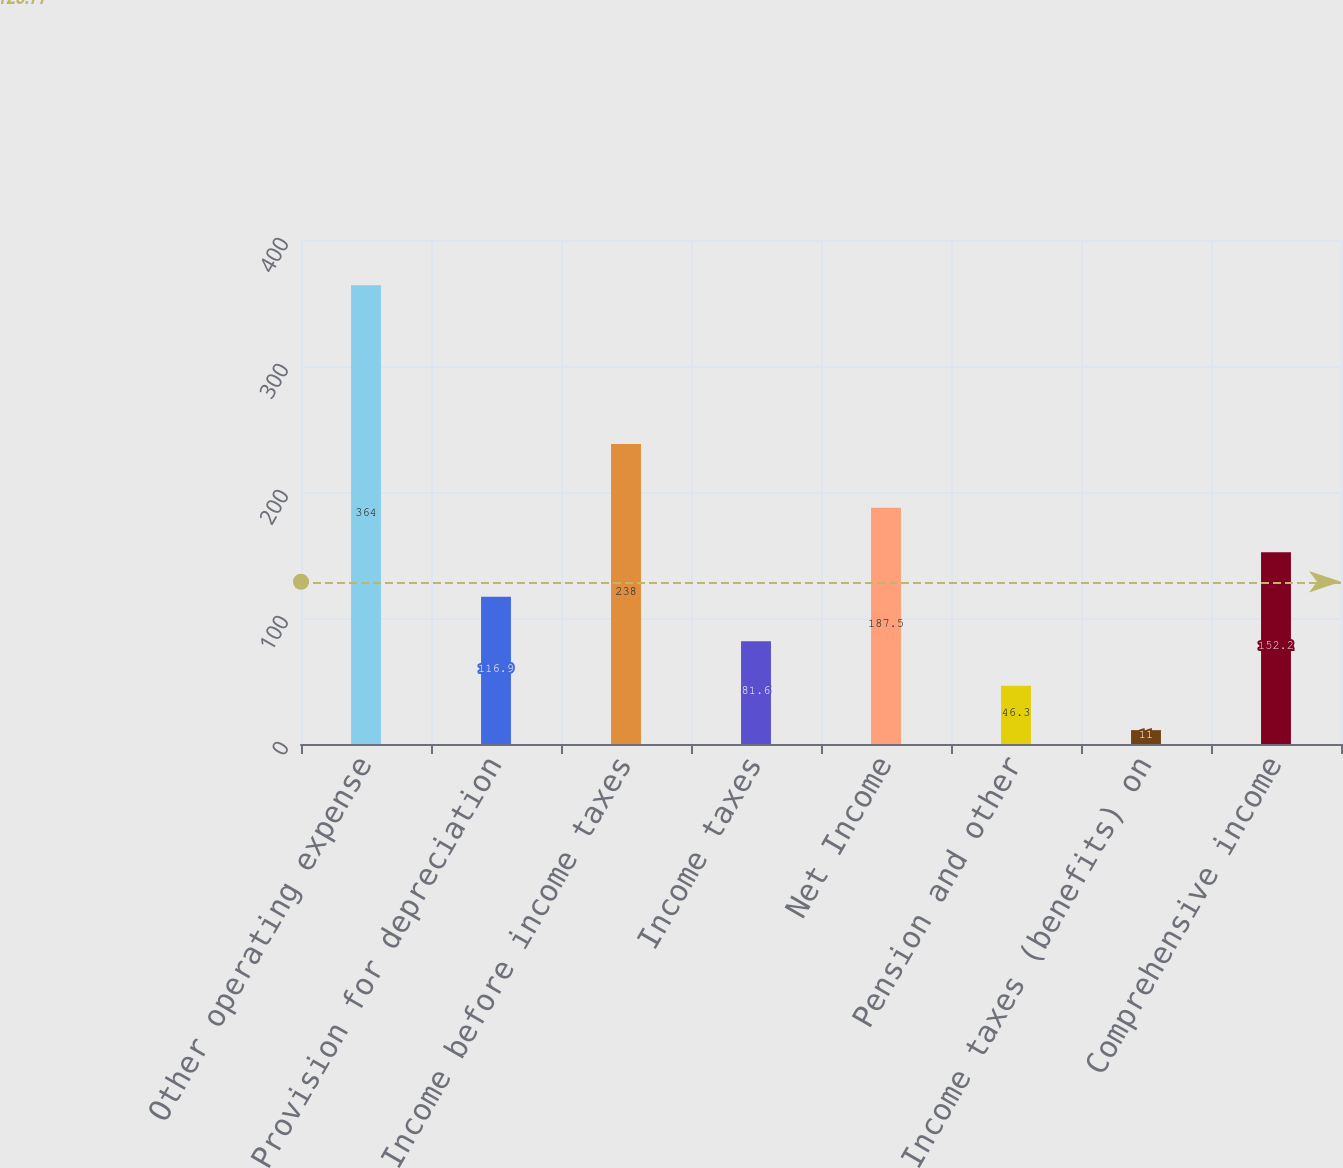Convert chart to OTSL. <chart><loc_0><loc_0><loc_500><loc_500><bar_chart><fcel>Other operating expense<fcel>Provision for depreciation<fcel>Income before income taxes<fcel>Income taxes<fcel>Net Income<fcel>Pension and other<fcel>Income taxes (benefits) on<fcel>Comprehensive income<nl><fcel>364<fcel>116.9<fcel>238<fcel>81.6<fcel>187.5<fcel>46.3<fcel>11<fcel>152.2<nl></chart> 